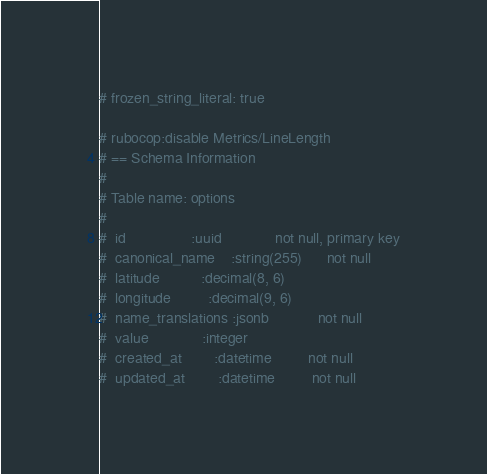<code> <loc_0><loc_0><loc_500><loc_500><_Ruby_># frozen_string_literal: true

# rubocop:disable Metrics/LineLength
# == Schema Information
#
# Table name: options
#
#  id                :uuid             not null, primary key
#  canonical_name    :string(255)      not null
#  latitude          :decimal(8, 6)
#  longitude         :decimal(9, 6)
#  name_translations :jsonb            not null
#  value             :integer
#  created_at        :datetime         not null
#  updated_at        :datetime         not null</code> 